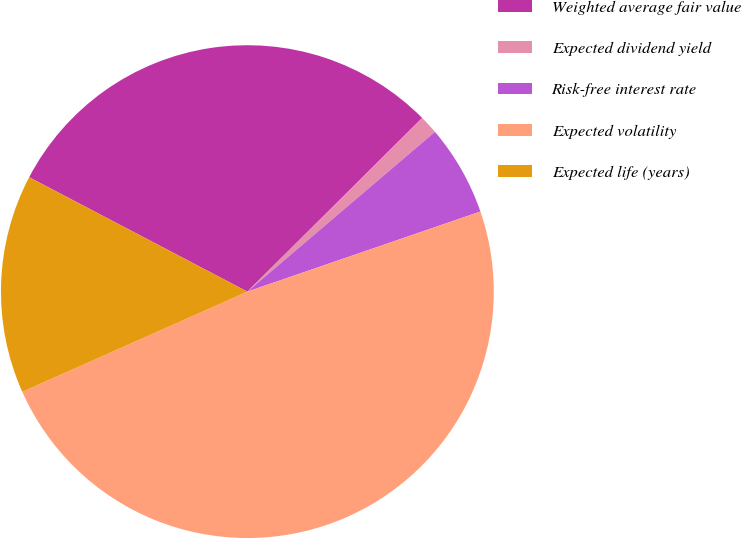Convert chart. <chart><loc_0><loc_0><loc_500><loc_500><pie_chart><fcel>Weighted average fair value<fcel>Expected dividend yield<fcel>Risk-free interest rate<fcel>Expected volatility<fcel>Expected life (years)<nl><fcel>29.87%<fcel>1.22%<fcel>5.96%<fcel>48.61%<fcel>14.35%<nl></chart> 